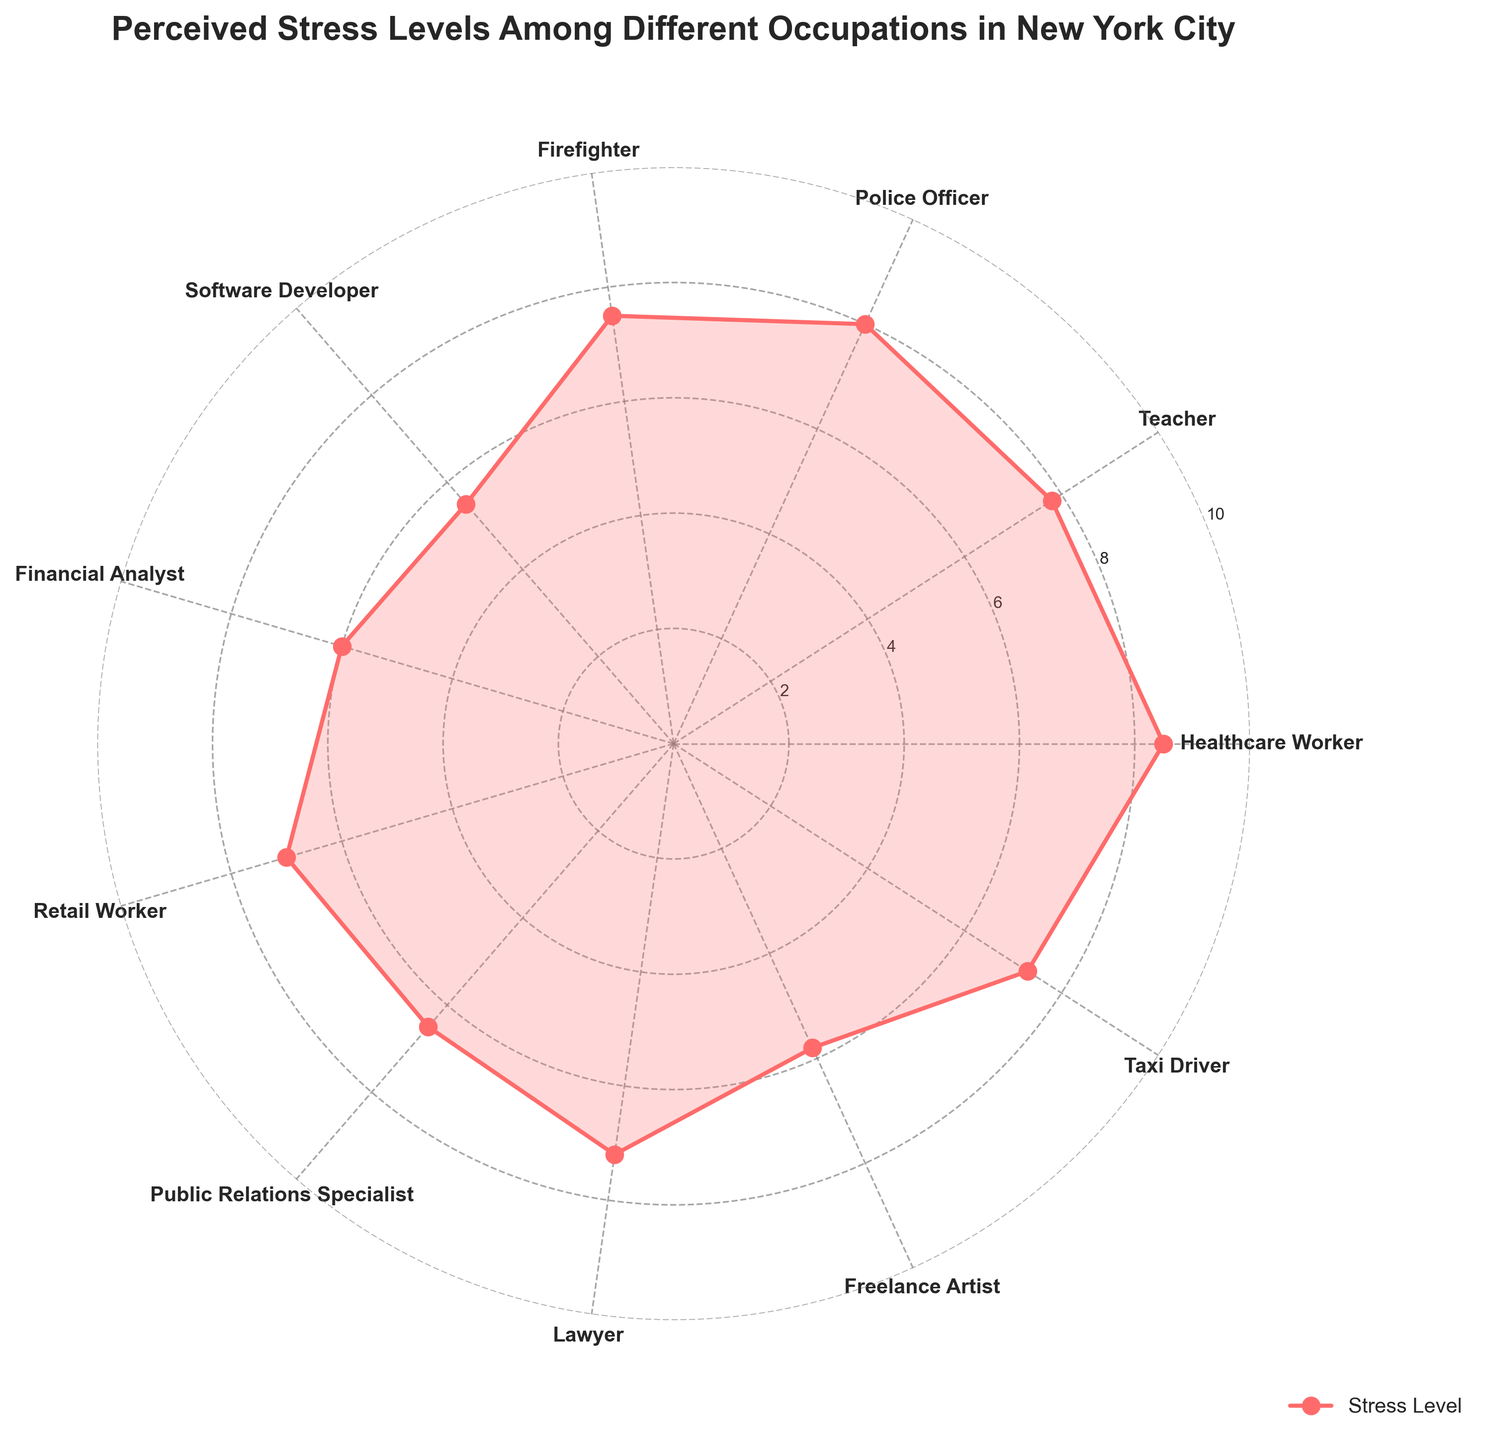What is the perceived stress level of a Healthcare Worker? The radar chart shows a point for each occupation indicating their perceived stress levels. The point for Healthcare Worker has a value on the radial axis at 8.5.
Answer: 8.5 Which occupation has the lowest perceived stress level? By examining each point on the radar chart and noting their locations, Software Developer has the lowest stress level at 5.5.
Answer: Software Developer What's the difference in perceived stress level between a Teacher and a Financial Analyst? The chart shows that a Teacher has a stress level of 7.8 and a Financial Analyst has a stress level of 6.0. The difference is 7.8 - 6.0 = 1.8.
Answer: 1.8 What is the combined perceived stress level for a Lawyer and a Taxi Driver? By looking at the chart, a Lawyer has a stress level of 7.2 and a Taxi Driver has a stress level of 7.3. Their combined stress level is 7.2 + 7.3 = 14.5.
Answer: 14.5 Is the perceived stress level of a Police Officer greater than that of a Freelance Artist? The chart shows that a Police Officer has a stress level of 8.0 and a Freelance Artist has a stress level of 5.8, hence 8.0 is greater than 5.8.
Answer: Yes Which occupation has a perceived stress level closest to the average of all occupations listed? The radar chart depicts 11 occupations. The average perceived stress level is (8.5+7.8+8.0+7.5+5.5+6.0+7.0+6.5+7.2+5.8+7.3)/11 = 6.927. The nearest value to 6.927 is 7.0, which belongs to Retail Worker.
Answer: Retail Worker What’s the range of perceived stress levels among all occupations? The chart shows the highest stress level being 8.5 (Healthcare Worker) and the lowest being 5.5 (Software Developer). The range is 8.5 - 5.5 = 3.0.
Answer: 3.0 How many occupations have a perceived stress level higher than 7.0? From the chart, Healthcare Worker (8.5), Teacher (7.8), Police Officer (8.0), Firefighter (7.5), Lawyer (7.2), and Taxi Driver (7.3) have stress levels above 7.0. This counts to 6 occupations.
Answer: 6 Is the perceived stress level of Public Relations Specialist equal to or less than that of a Financial Analyst? The radar chart shows a Public Relations Specialist with a stress level of 6.5 and a Financial Analyst with a stress level of 6.0. Since 6.5 is greater than 6.0, the answer is no.
Answer: No 